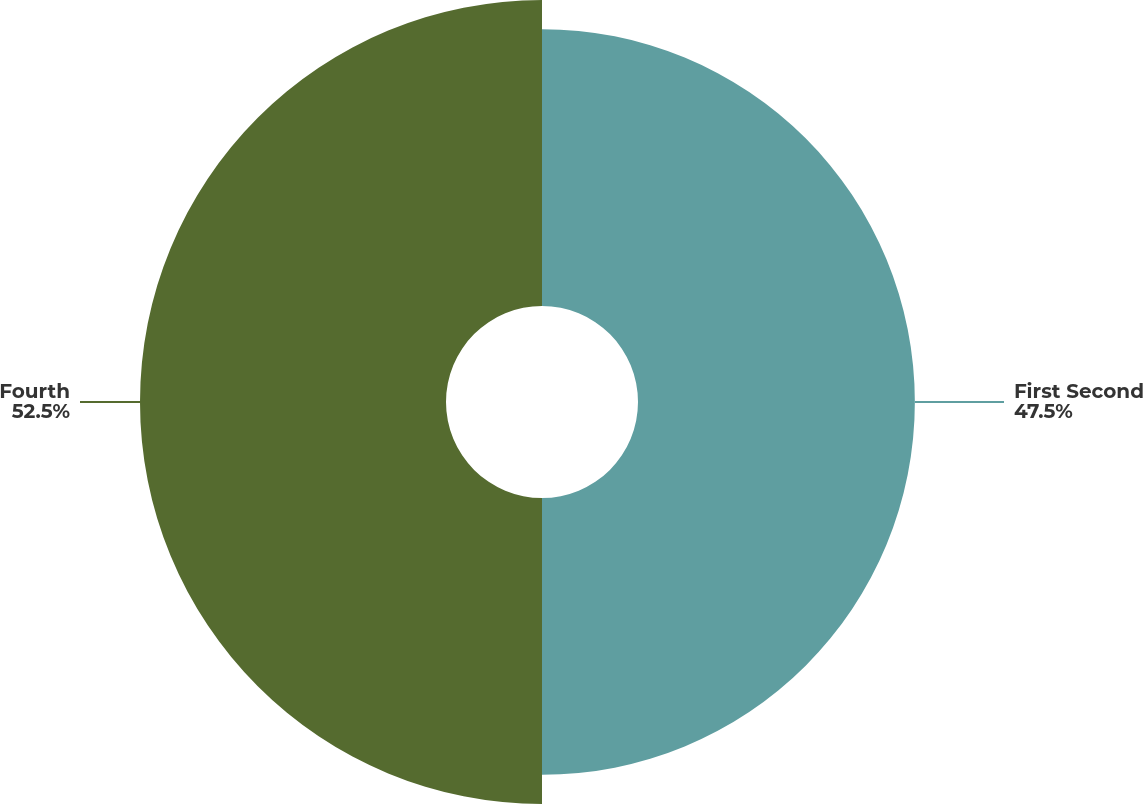Convert chart. <chart><loc_0><loc_0><loc_500><loc_500><pie_chart><fcel>First Second<fcel>Fourth<nl><fcel>47.5%<fcel>52.5%<nl></chart> 